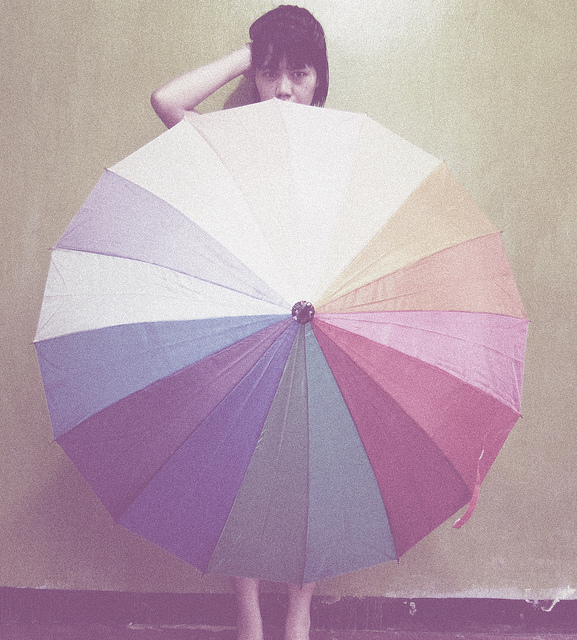<image>Is the lady wearing a bikini? I don't know if the lady is wearing a bikini. It can be either 'yes' or 'no'. Is the lady wearing a bikini? I don't know if the lady is wearing a bikini. It can be both yes or no. 